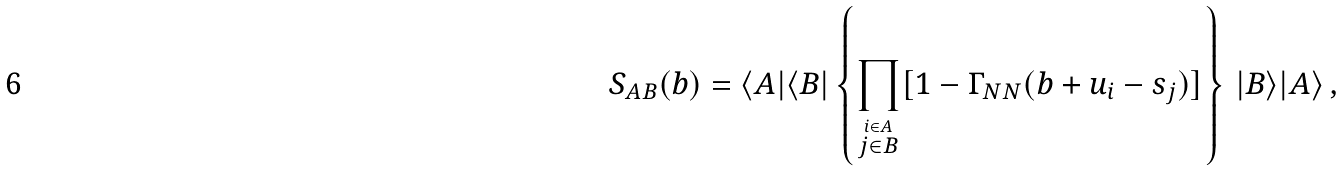Convert formula to latex. <formula><loc_0><loc_0><loc_500><loc_500>S _ { A B } ( b ) = \langle A | \langle B | \left \{ \prod _ { \stackrel { i \in A } { j \in B } } [ 1 - \Gamma _ { N N } ( b + u _ { i } - s _ { j } ) ] \right \} \, | B \rangle | A \rangle \, ,</formula> 